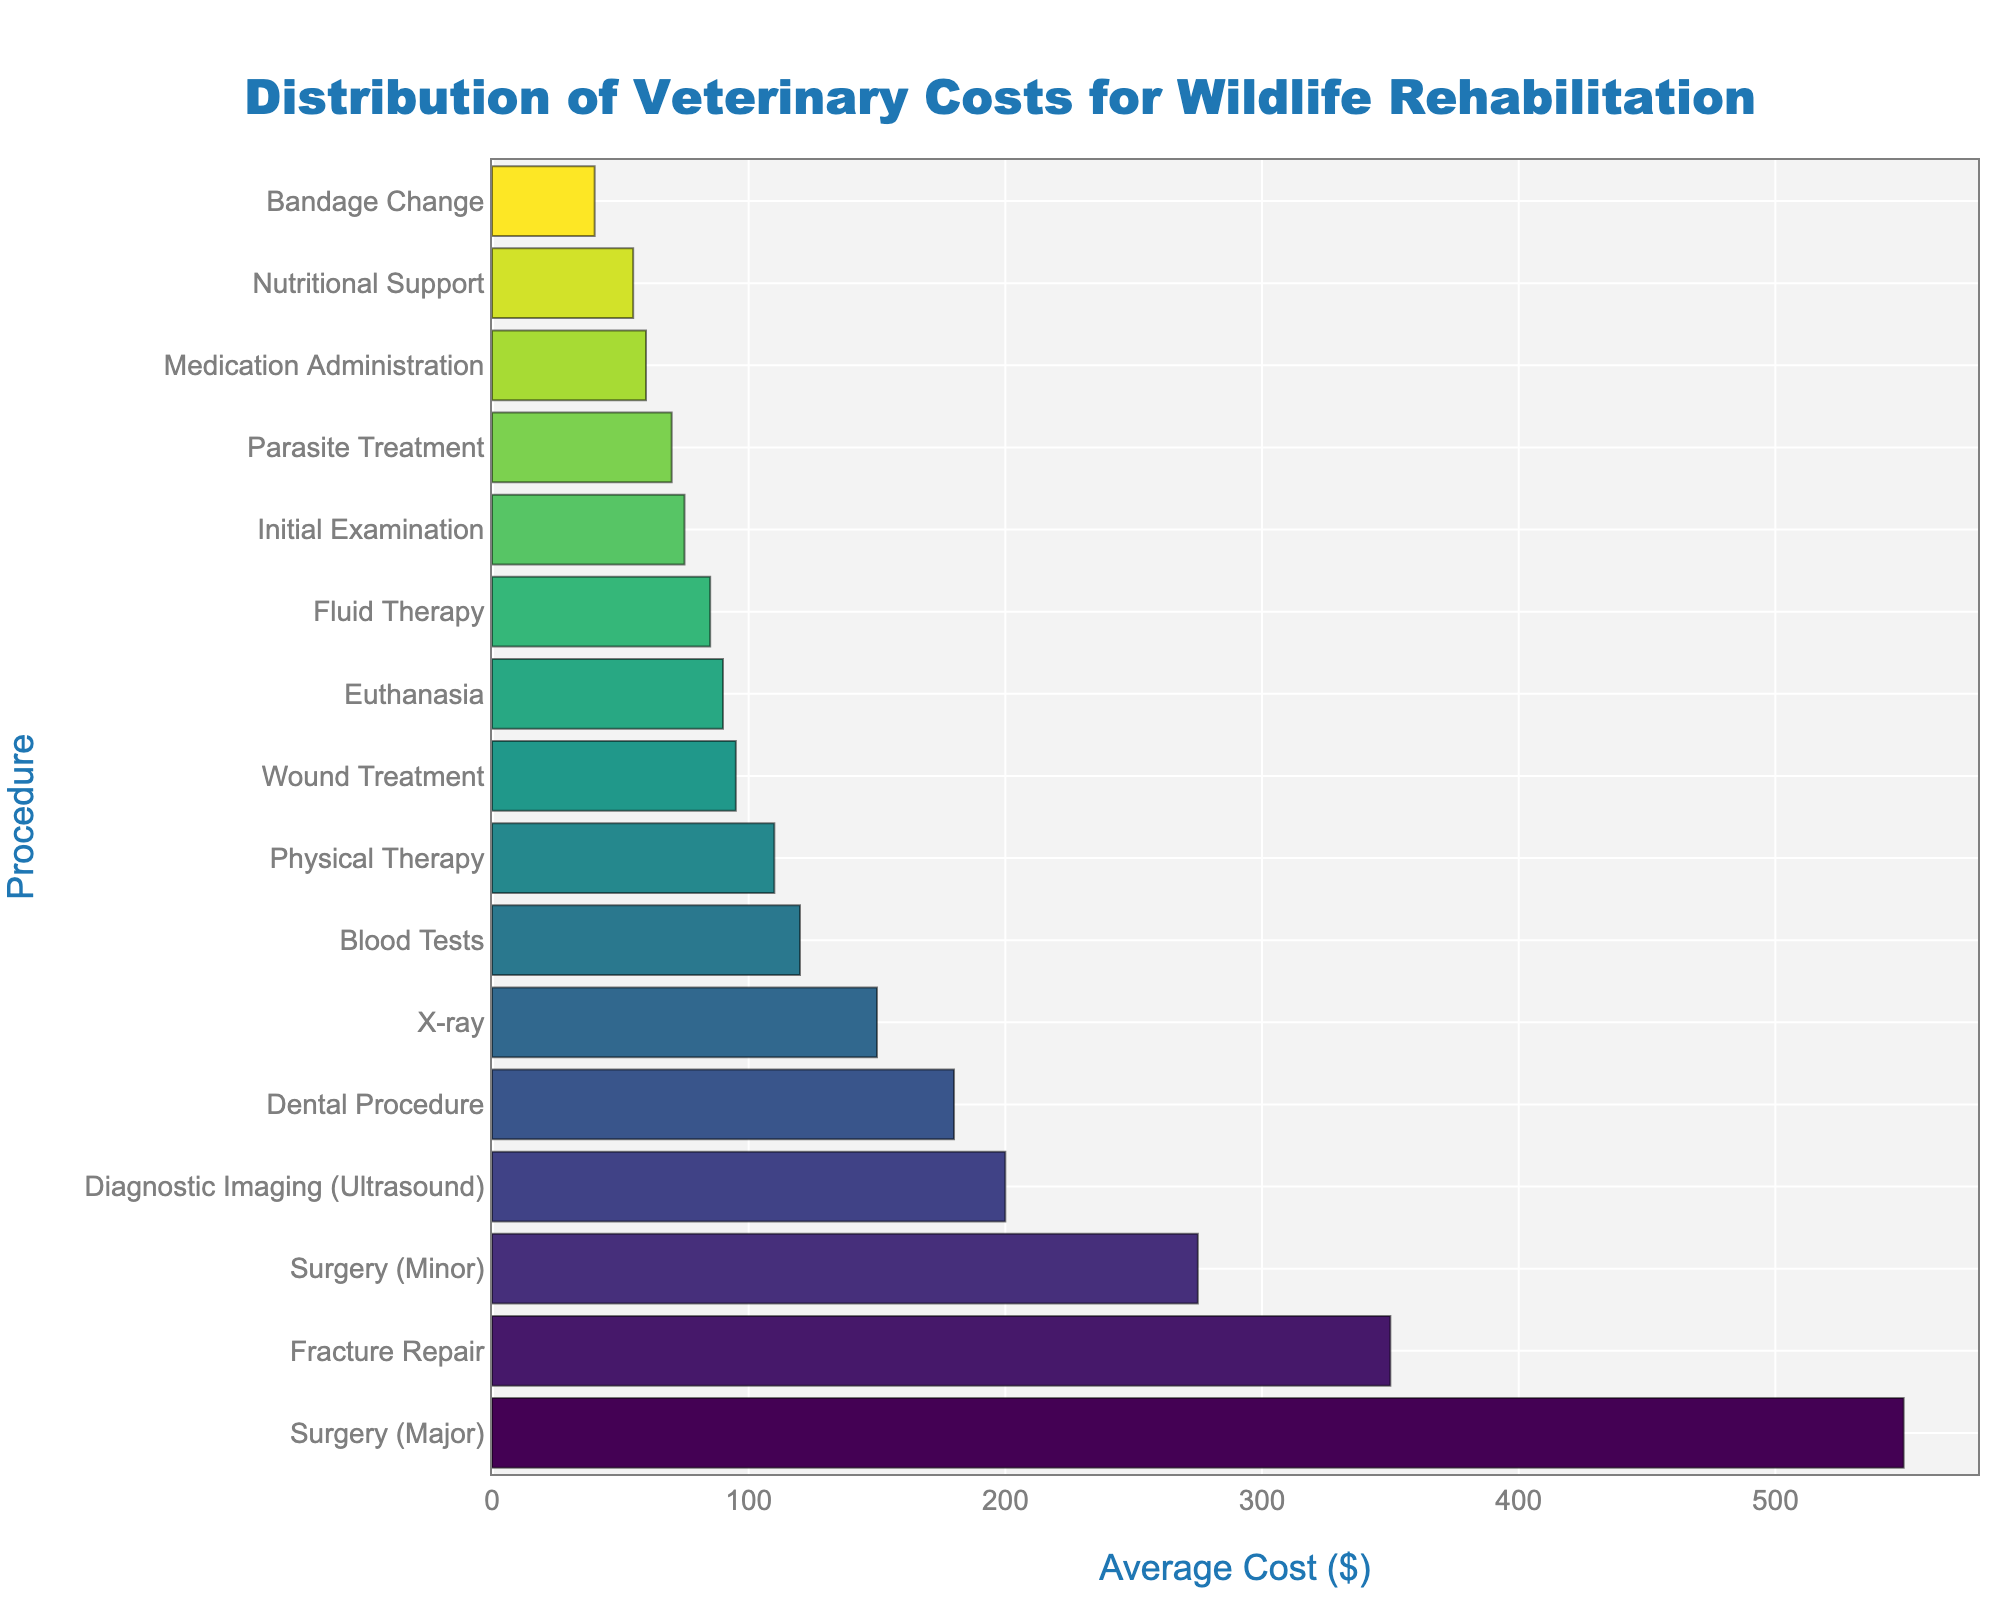Which procedure has the highest average cost? The bar chart shows the costs for procedures in descending order from top to bottom. The procedure at the top has the highest average cost.
Answer: Surgery (Major) Which procedure costs more: Diagnostic Imaging (Ultrasound) or Dental Procedure? By comparing the lengths of the bars corresponding to Diagnostic Imaging (Ultrasound) and Dental Procedure, we see which one is longer and thus more costly.
Answer: Diagnostic Imaging (Ultrasound) What is the average cost of Blood Tests and Fluid Therapy combined? Look at the average costs for Blood Tests and Fluid Therapy on the chart. Add these values together: 120 + 85 = 205. Then divide by 2 to find the average: 205 / 2 = 102.5.
Answer: 102.5 How many procedures cost more than 200 dollars? Count the number of bars with lengths corresponding to costs greater than 200 dollars.
Answer: 3 Which is cheaper, Initial Examination or Medication Administration? Compare the lengths of the bars for Initial Examination and Medication Administration. The shorter bar represents the cheaper procedure.
Answer: Medication Administration What is the difference in cost between Surgery (Major) and Surgery (Minor)? Find the lengths of the bars for Surgery (Major) and Surgery (Minor) and subtract the cost of Surgery (Minor) from Surgery (Major): 550 - 275 = 275.
Answer: 275 Are more than half the procedures above or below 100 dollars? Determine the median procedure cost and count the number of procedures above and below this cost. There are 16 procedures, so check if more than 8 procedures are above or below 100 dollars.
Answer: Below What is the cost of the most common type of diagnostic procedure? Diagnostic procedures include X-ray, Blood Tests, and Diagnostic Imaging (Ultrasound). Identify the one most commonly used in veterinary practice and refer to its cost in the chart.
Answer: X-ray, 150 Which procedure involving regular maintenance has the lowest cost? Procedures such as Bandage Change, Medication Administration, and Physical Therapy are considered maintenance. Compare their costs in the chart to identify the lowest.
Answer: Bandage Change What is the total cost of three Surgical Procedures (Minor), if needed for different animals? Multiply the cost of Surgery (Minor) by three to get the total: 275 * 3 = 825.
Answer: 825 